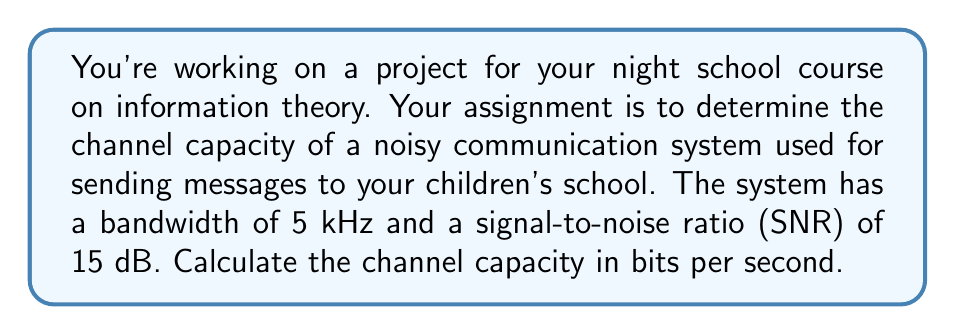Can you solve this math problem? To solve this problem, we'll use the Shannon-Hartley theorem, which gives the channel capacity for a noisy communication channel. The theorem is expressed as:

$$C = B \log_2(1 + SNR)$$

Where:
$C$ is the channel capacity in bits per second
$B$ is the bandwidth in Hz
$SNR$ is the signal-to-noise ratio

Given:
- Bandwidth, $B = 5 \text{ kHz} = 5000 \text{ Hz}$
- SNR = 15 dB

Step 1: Convert SNR from dB to linear scale
The SNR in dB needs to be converted to a linear scale using the formula:
$$SNR_{linear} = 10^{SNR_{dB}/10}$$

$$SNR_{linear} = 10^{15/10} = 10^{1.5} \approx 31.6228$$

Step 2: Apply the Shannon-Hartley theorem
Now we can substitute the values into the channel capacity formula:

$$\begin{align}
C &= B \log_2(1 + SNR) \\
&= 5000 \cdot \log_2(1 + 31.6228) \\
&= 5000 \cdot \log_2(32.6228) \\
&\approx 5000 \cdot 5.0279 \\
&\approx 25,139.5 \text{ bits per second}
\end{align}$$

Step 3: Round the result
Rounding to the nearest whole number, we get 25,140 bits per second.
Answer: The channel capacity is approximately 25,140 bits per second. 